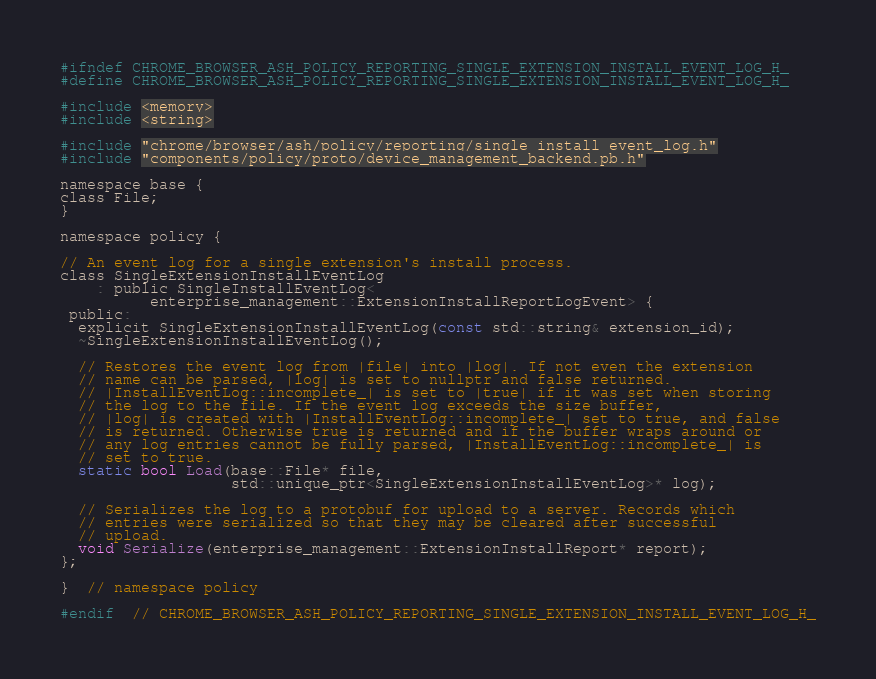<code> <loc_0><loc_0><loc_500><loc_500><_C_>
#ifndef CHROME_BROWSER_ASH_POLICY_REPORTING_SINGLE_EXTENSION_INSTALL_EVENT_LOG_H_
#define CHROME_BROWSER_ASH_POLICY_REPORTING_SINGLE_EXTENSION_INSTALL_EVENT_LOG_H_

#include <memory>
#include <string>

#include "chrome/browser/ash/policy/reporting/single_install_event_log.h"
#include "components/policy/proto/device_management_backend.pb.h"

namespace base {
class File;
}

namespace policy {

// An event log for a single extension's install process.
class SingleExtensionInstallEventLog
    : public SingleInstallEventLog<
          enterprise_management::ExtensionInstallReportLogEvent> {
 public:
  explicit SingleExtensionInstallEventLog(const std::string& extension_id);
  ~SingleExtensionInstallEventLog();

  // Restores the event log from |file| into |log|. If not even the extension
  // name can be parsed, |log| is set to nullptr and false returned.
  // |InstallEventLog::incomplete_| is set to |true| if it was set when storing
  // the log to the file. If the event log exceeds the size buffer,
  // |log| is created with |InstallEventLog::incomplete_| set to true, and false
  // is returned. Otherwise true is returned and if the buffer wraps around or
  // any log entries cannot be fully parsed, |InstallEventLog::incomplete_| is
  // set to true.
  static bool Load(base::File* file,
                   std::unique_ptr<SingleExtensionInstallEventLog>* log);

  // Serializes the log to a protobuf for upload to a server. Records which
  // entries were serialized so that they may be cleared after successful
  // upload.
  void Serialize(enterprise_management::ExtensionInstallReport* report);
};

}  // namespace policy

#endif  // CHROME_BROWSER_ASH_POLICY_REPORTING_SINGLE_EXTENSION_INSTALL_EVENT_LOG_H_
</code> 